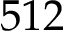<formula> <loc_0><loc_0><loc_500><loc_500>5 1 2</formula> 